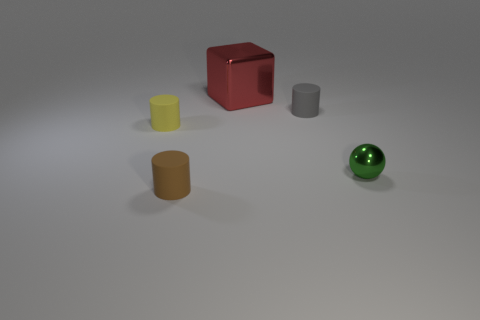Subtract all brown cylinders. How many cylinders are left? 2 Subtract all cubes. How many objects are left? 4 Add 1 tiny green shiny objects. How many objects exist? 6 Subtract all brown cylinders. How many cylinders are left? 2 Subtract 0 brown cubes. How many objects are left? 5 Subtract all red balls. Subtract all red cylinders. How many balls are left? 1 Subtract all brown spheres. How many brown cylinders are left? 1 Subtract all small yellow rubber objects. Subtract all blocks. How many objects are left? 3 Add 1 small green metal spheres. How many small green metal spheres are left? 2 Add 5 big red metallic things. How many big red metallic things exist? 6 